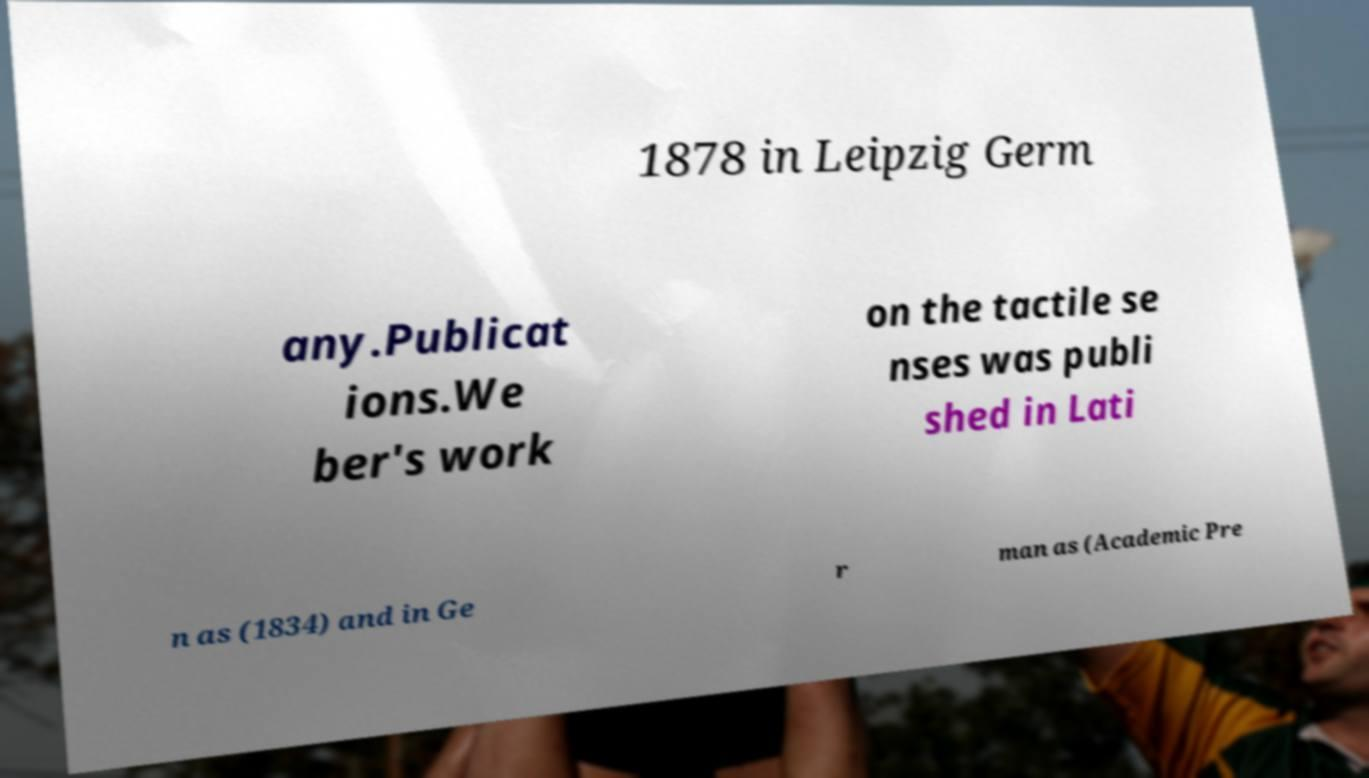Could you assist in decoding the text presented in this image and type it out clearly? 1878 in Leipzig Germ any.Publicat ions.We ber's work on the tactile se nses was publi shed in Lati n as (1834) and in Ge r man as (Academic Pre 